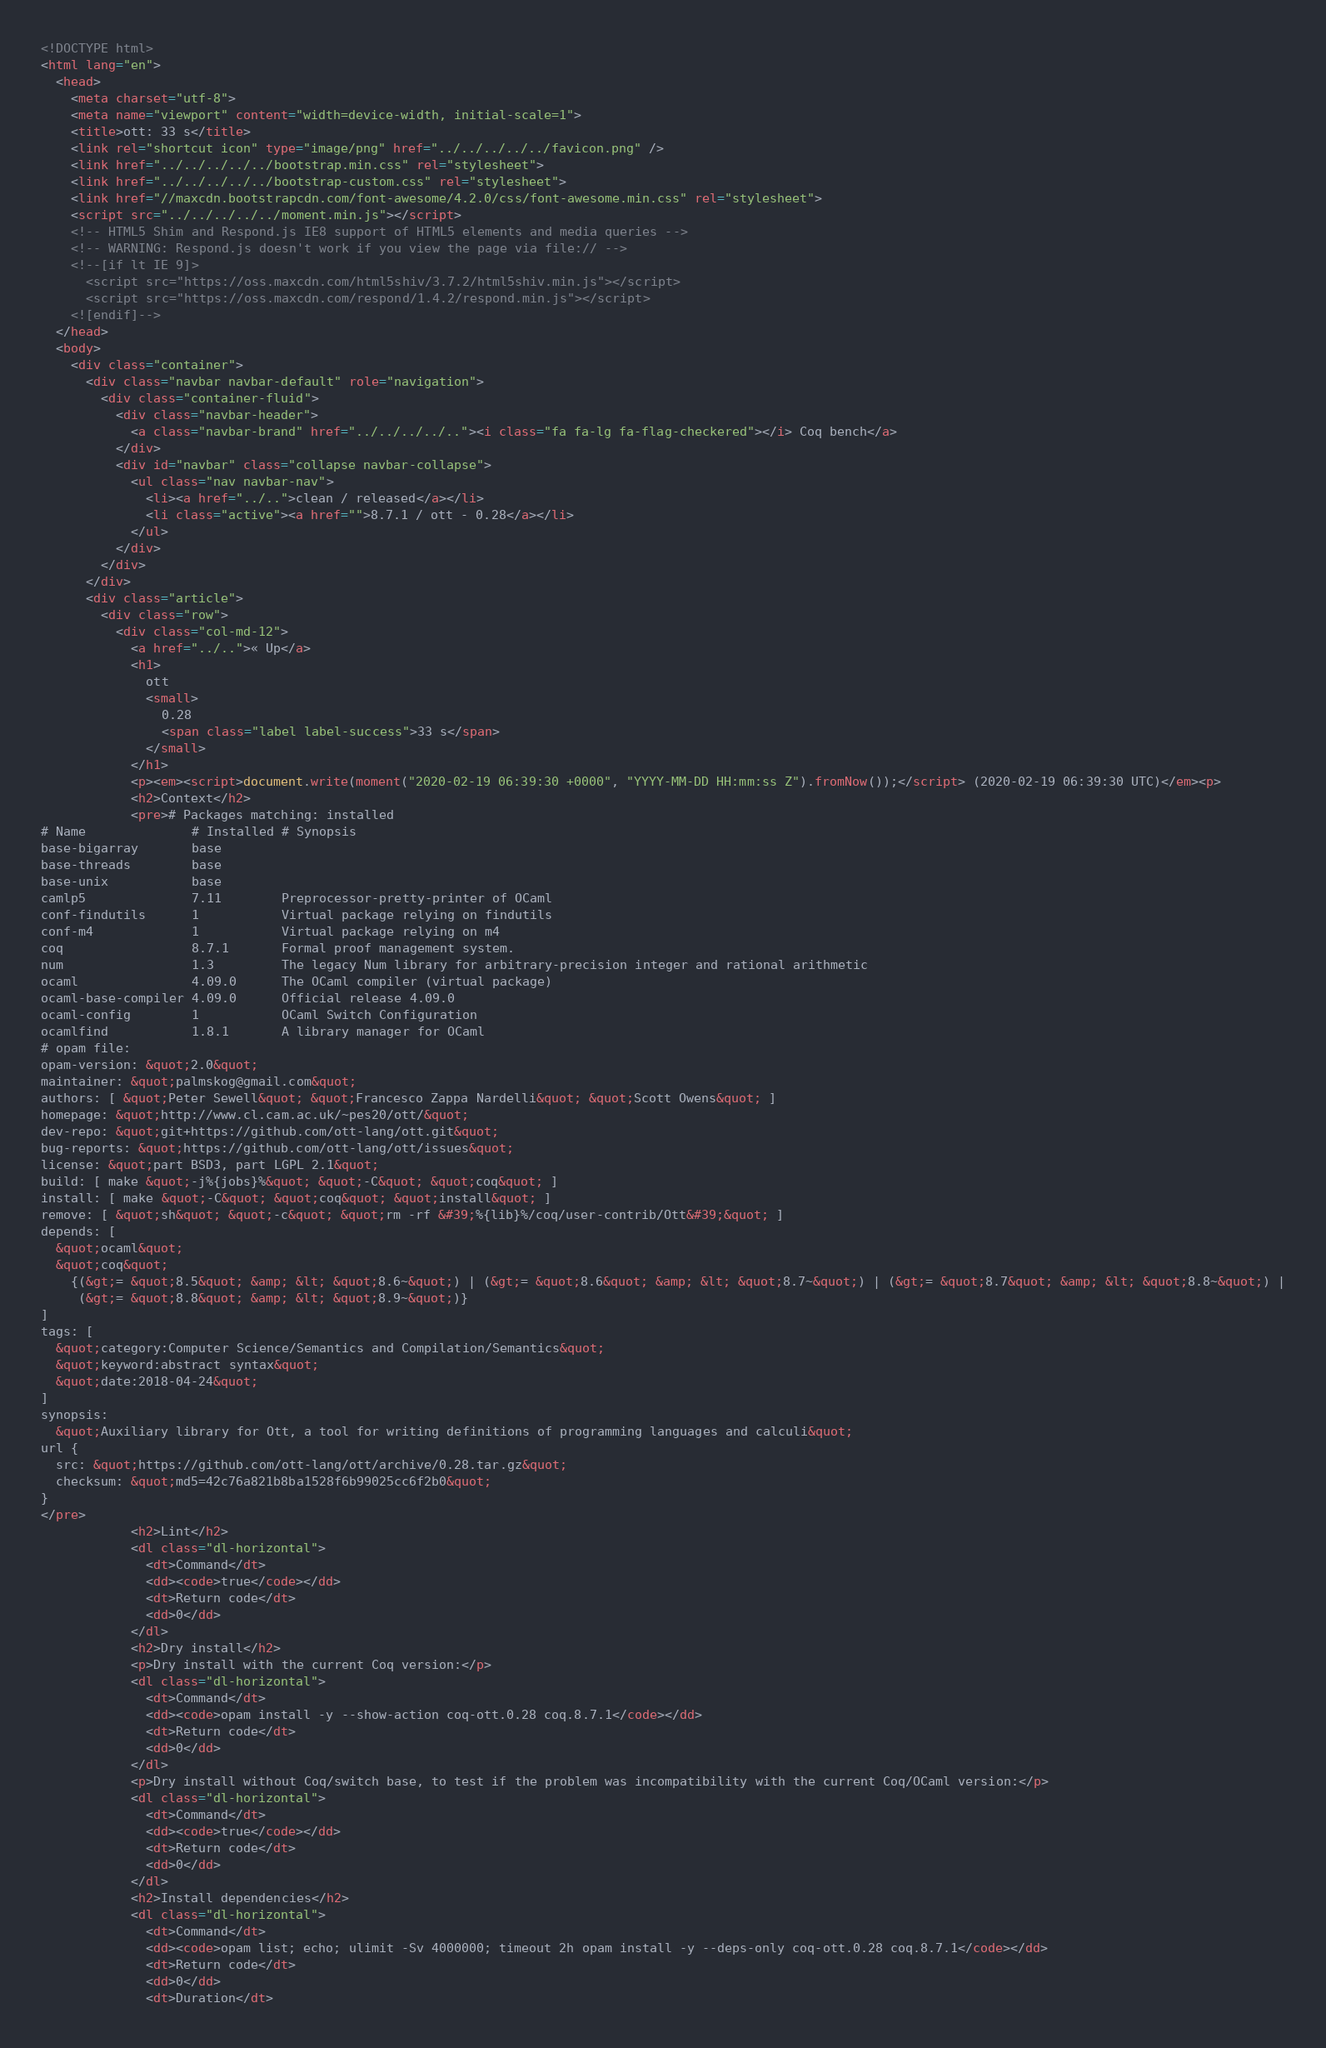<code> <loc_0><loc_0><loc_500><loc_500><_HTML_><!DOCTYPE html>
<html lang="en">
  <head>
    <meta charset="utf-8">
    <meta name="viewport" content="width=device-width, initial-scale=1">
    <title>ott: 33 s</title>
    <link rel="shortcut icon" type="image/png" href="../../../../../favicon.png" />
    <link href="../../../../../bootstrap.min.css" rel="stylesheet">
    <link href="../../../../../bootstrap-custom.css" rel="stylesheet">
    <link href="//maxcdn.bootstrapcdn.com/font-awesome/4.2.0/css/font-awesome.min.css" rel="stylesheet">
    <script src="../../../../../moment.min.js"></script>
    <!-- HTML5 Shim and Respond.js IE8 support of HTML5 elements and media queries -->
    <!-- WARNING: Respond.js doesn't work if you view the page via file:// -->
    <!--[if lt IE 9]>
      <script src="https://oss.maxcdn.com/html5shiv/3.7.2/html5shiv.min.js"></script>
      <script src="https://oss.maxcdn.com/respond/1.4.2/respond.min.js"></script>
    <![endif]-->
  </head>
  <body>
    <div class="container">
      <div class="navbar navbar-default" role="navigation">
        <div class="container-fluid">
          <div class="navbar-header">
            <a class="navbar-brand" href="../../../../.."><i class="fa fa-lg fa-flag-checkered"></i> Coq bench</a>
          </div>
          <div id="navbar" class="collapse navbar-collapse">
            <ul class="nav navbar-nav">
              <li><a href="../..">clean / released</a></li>
              <li class="active"><a href="">8.7.1 / ott - 0.28</a></li>
            </ul>
          </div>
        </div>
      </div>
      <div class="article">
        <div class="row">
          <div class="col-md-12">
            <a href="../..">« Up</a>
            <h1>
              ott
              <small>
                0.28
                <span class="label label-success">33 s</span>
              </small>
            </h1>
            <p><em><script>document.write(moment("2020-02-19 06:39:30 +0000", "YYYY-MM-DD HH:mm:ss Z").fromNow());</script> (2020-02-19 06:39:30 UTC)</em><p>
            <h2>Context</h2>
            <pre># Packages matching: installed
# Name              # Installed # Synopsis
base-bigarray       base
base-threads        base
base-unix           base
camlp5              7.11        Preprocessor-pretty-printer of OCaml
conf-findutils      1           Virtual package relying on findutils
conf-m4             1           Virtual package relying on m4
coq                 8.7.1       Formal proof management system.
num                 1.3         The legacy Num library for arbitrary-precision integer and rational arithmetic
ocaml               4.09.0      The OCaml compiler (virtual package)
ocaml-base-compiler 4.09.0      Official release 4.09.0
ocaml-config        1           OCaml Switch Configuration
ocamlfind           1.8.1       A library manager for OCaml
# opam file:
opam-version: &quot;2.0&quot;
maintainer: &quot;palmskog@gmail.com&quot;
authors: [ &quot;Peter Sewell&quot; &quot;Francesco Zappa Nardelli&quot; &quot;Scott Owens&quot; ]
homepage: &quot;http://www.cl.cam.ac.uk/~pes20/ott/&quot;
dev-repo: &quot;git+https://github.com/ott-lang/ott.git&quot;
bug-reports: &quot;https://github.com/ott-lang/ott/issues&quot;
license: &quot;part BSD3, part LGPL 2.1&quot;
build: [ make &quot;-j%{jobs}%&quot; &quot;-C&quot; &quot;coq&quot; ]
install: [ make &quot;-C&quot; &quot;coq&quot; &quot;install&quot; ]
remove: [ &quot;sh&quot; &quot;-c&quot; &quot;rm -rf &#39;%{lib}%/coq/user-contrib/Ott&#39;&quot; ]
depends: [
  &quot;ocaml&quot;
  &quot;coq&quot;
    {(&gt;= &quot;8.5&quot; &amp; &lt; &quot;8.6~&quot;) | (&gt;= &quot;8.6&quot; &amp; &lt; &quot;8.7~&quot;) | (&gt;= &quot;8.7&quot; &amp; &lt; &quot;8.8~&quot;) |
     (&gt;= &quot;8.8&quot; &amp; &lt; &quot;8.9~&quot;)}
]
tags: [
  &quot;category:Computer Science/Semantics and Compilation/Semantics&quot;
  &quot;keyword:abstract syntax&quot;
  &quot;date:2018-04-24&quot;
]
synopsis:
  &quot;Auxiliary library for Ott, a tool for writing definitions of programming languages and calculi&quot;
url {
  src: &quot;https://github.com/ott-lang/ott/archive/0.28.tar.gz&quot;
  checksum: &quot;md5=42c76a821b8ba1528f6b99025cc6f2b0&quot;
}
</pre>
            <h2>Lint</h2>
            <dl class="dl-horizontal">
              <dt>Command</dt>
              <dd><code>true</code></dd>
              <dt>Return code</dt>
              <dd>0</dd>
            </dl>
            <h2>Dry install</h2>
            <p>Dry install with the current Coq version:</p>
            <dl class="dl-horizontal">
              <dt>Command</dt>
              <dd><code>opam install -y --show-action coq-ott.0.28 coq.8.7.1</code></dd>
              <dt>Return code</dt>
              <dd>0</dd>
            </dl>
            <p>Dry install without Coq/switch base, to test if the problem was incompatibility with the current Coq/OCaml version:</p>
            <dl class="dl-horizontal">
              <dt>Command</dt>
              <dd><code>true</code></dd>
              <dt>Return code</dt>
              <dd>0</dd>
            </dl>
            <h2>Install dependencies</h2>
            <dl class="dl-horizontal">
              <dt>Command</dt>
              <dd><code>opam list; echo; ulimit -Sv 4000000; timeout 2h opam install -y --deps-only coq-ott.0.28 coq.8.7.1</code></dd>
              <dt>Return code</dt>
              <dd>0</dd>
              <dt>Duration</dt></code> 